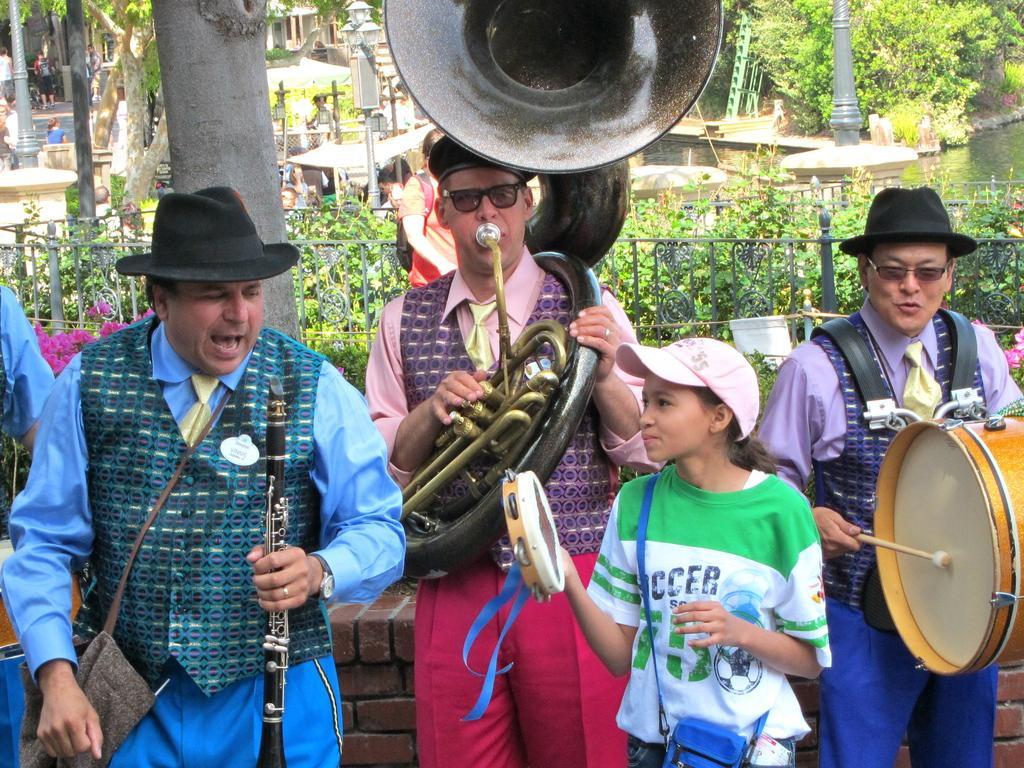How would you summarize this image in a sentence or two? There are group of persons playing music and there are trees and river behind them. 